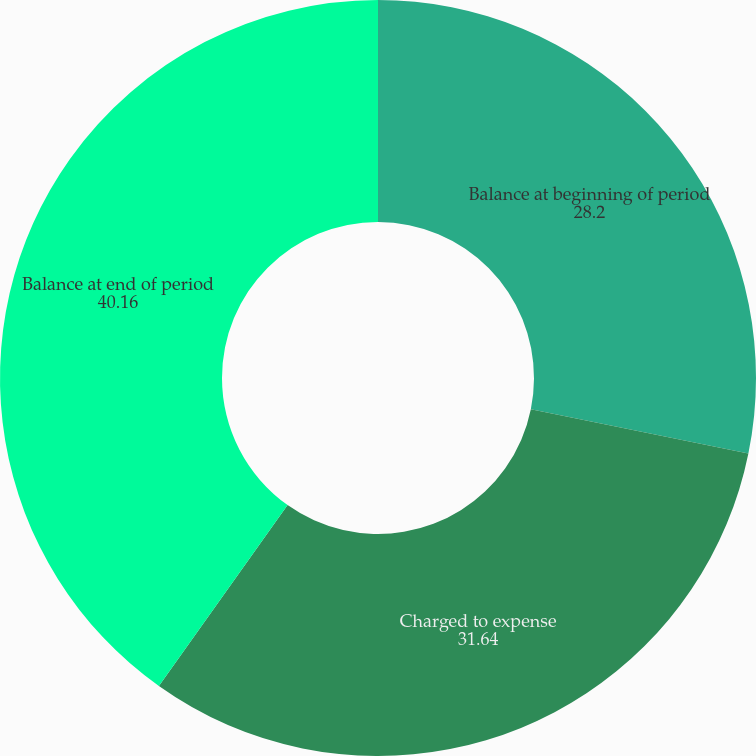Convert chart. <chart><loc_0><loc_0><loc_500><loc_500><pie_chart><fcel>Balance at beginning of period<fcel>Charged to expense<fcel>Balance at end of period<nl><fcel>28.2%<fcel>31.64%<fcel>40.16%<nl></chart> 